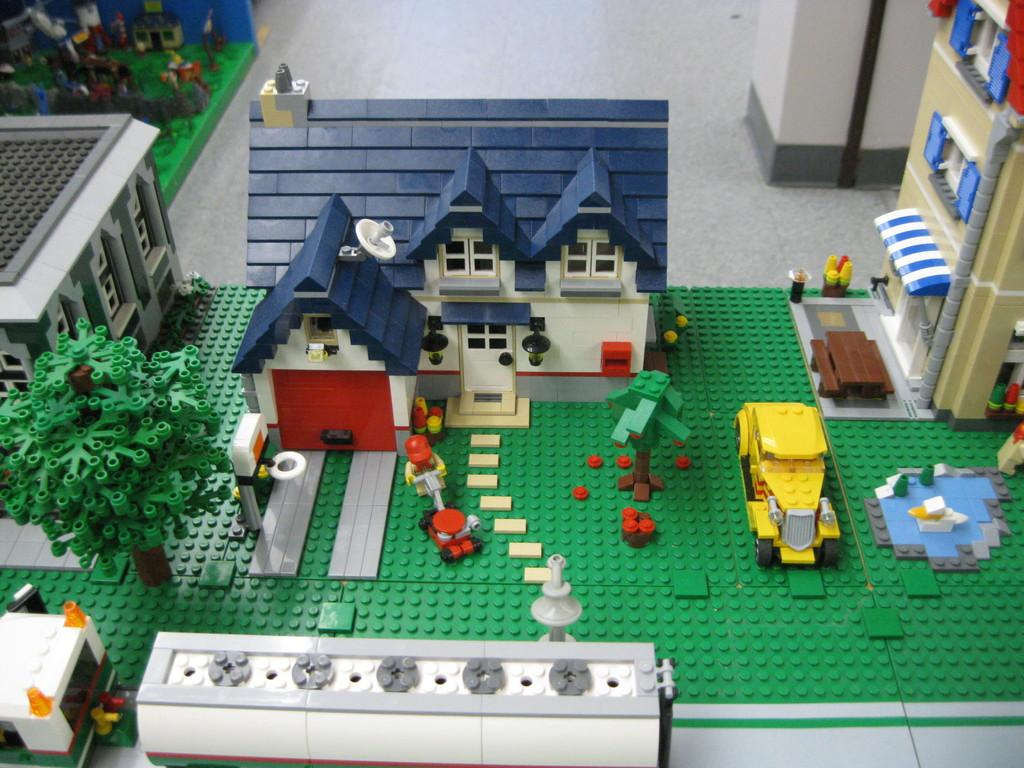What type of structures are present in the image? There are buildings with windows in the image. What other elements can be seen in the image? There are trees and vehicles in the image. What material are the buildings, trees, and vehicles made of? The buildings, trees, and vehicles are made of building blocks. What sense is being used by the trees in the image? Trees do not have senses, as they are inanimate objects made of building blocks in this image. 